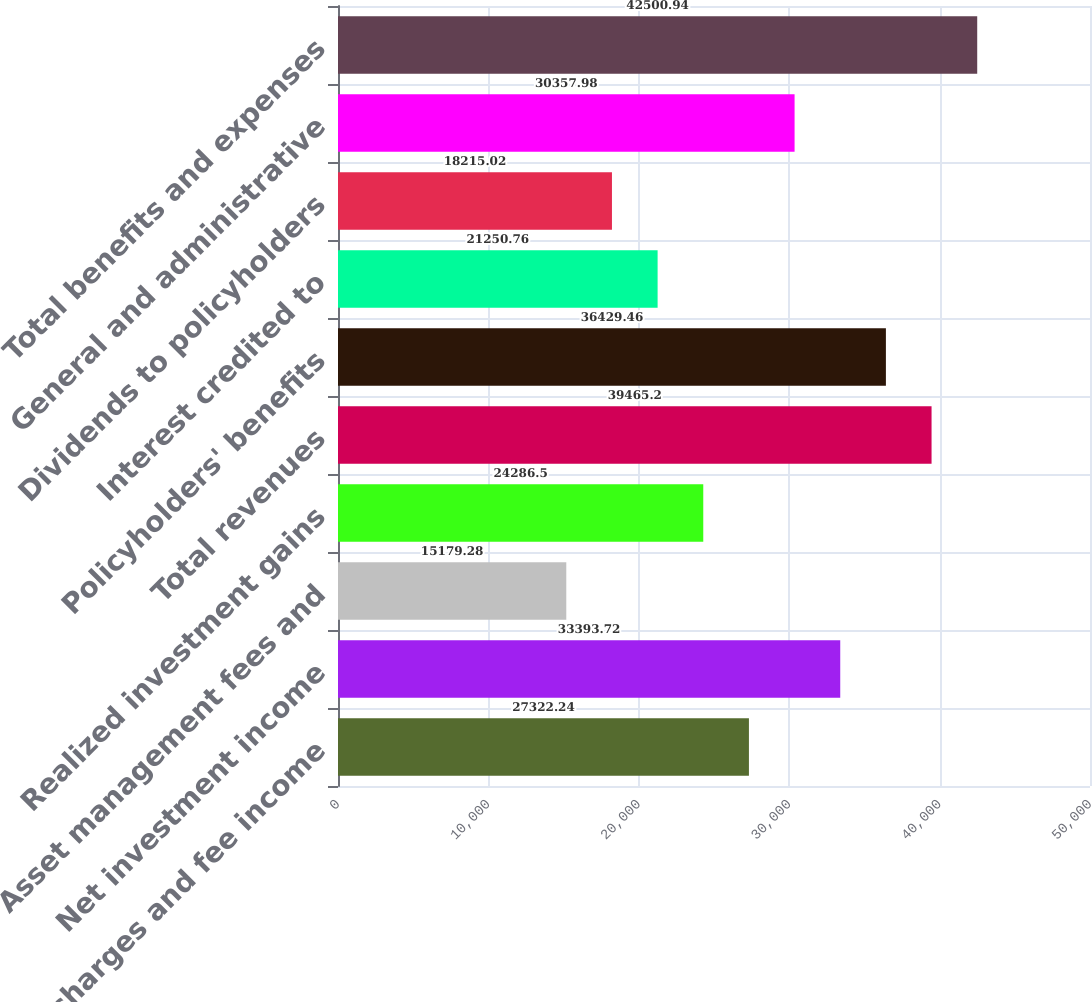Convert chart. <chart><loc_0><loc_0><loc_500><loc_500><bar_chart><fcel>Policy charges and fee income<fcel>Net investment income<fcel>Asset management fees and<fcel>Realized investment gains<fcel>Total revenues<fcel>Policyholders' benefits<fcel>Interest credited to<fcel>Dividends to policyholders<fcel>General and administrative<fcel>Total benefits and expenses<nl><fcel>27322.2<fcel>33393.7<fcel>15179.3<fcel>24286.5<fcel>39465.2<fcel>36429.5<fcel>21250.8<fcel>18215<fcel>30358<fcel>42500.9<nl></chart> 